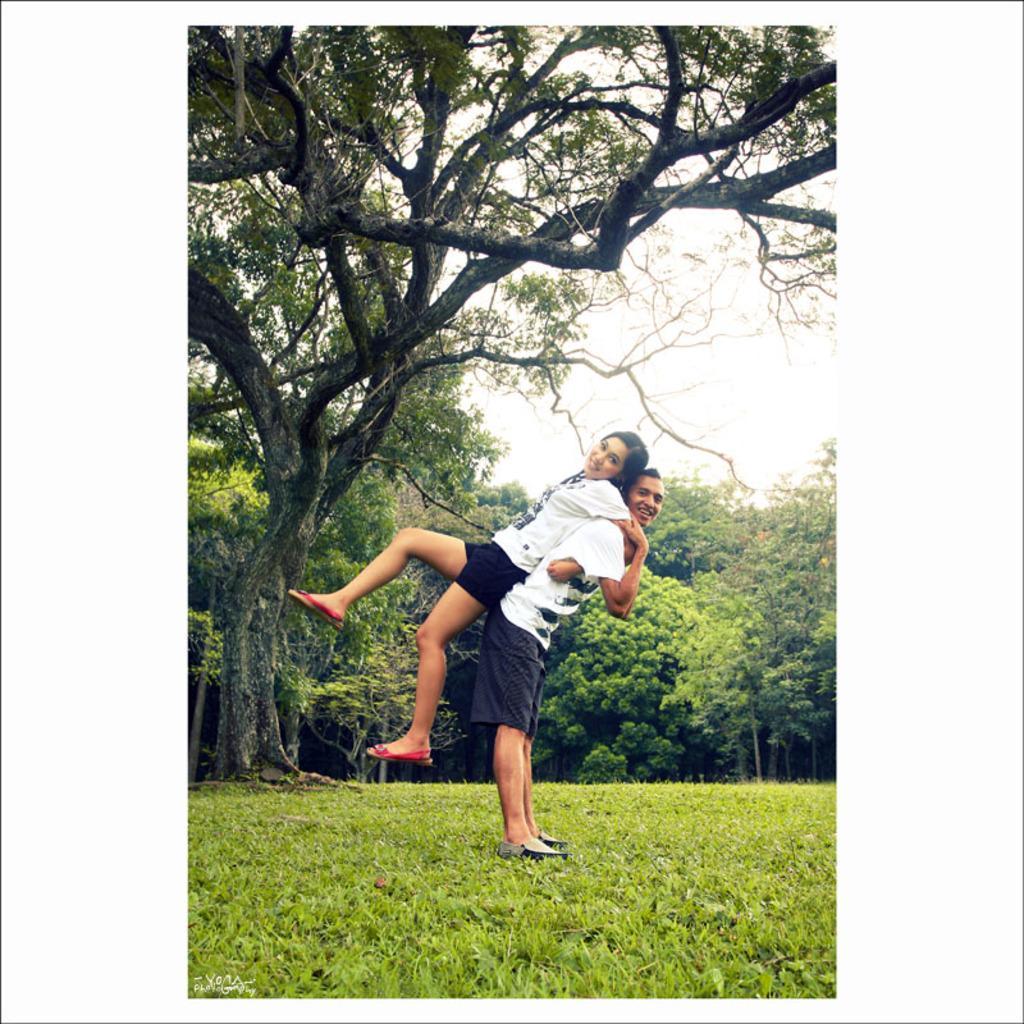Please provide a concise description of this image. In this picture we can see a man standing on the grass and he is carrying a woman. Behind the two persons, there are trees and the sky. In the bottom left corner of the image, there is a watermark. 